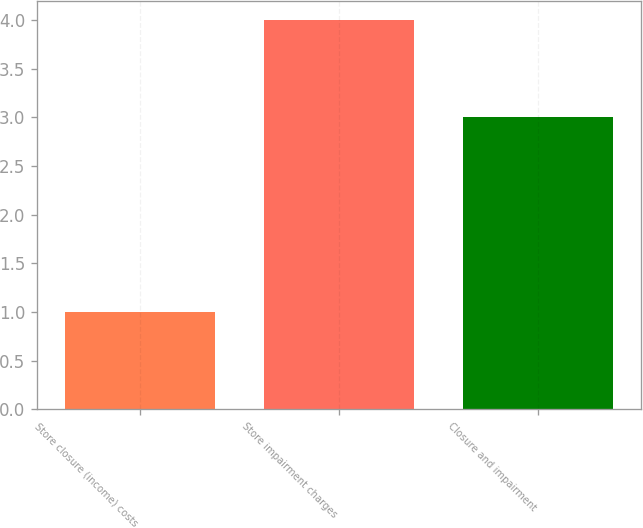Convert chart to OTSL. <chart><loc_0><loc_0><loc_500><loc_500><bar_chart><fcel>Store closure (income) costs<fcel>Store impairment charges<fcel>Closure and impairment<nl><fcel>1<fcel>4<fcel>3<nl></chart> 